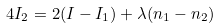Convert formula to latex. <formula><loc_0><loc_0><loc_500><loc_500>4 I _ { 2 } = 2 ( I - I _ { 1 } ) + \lambda ( n _ { 1 } - n _ { 2 } )</formula> 